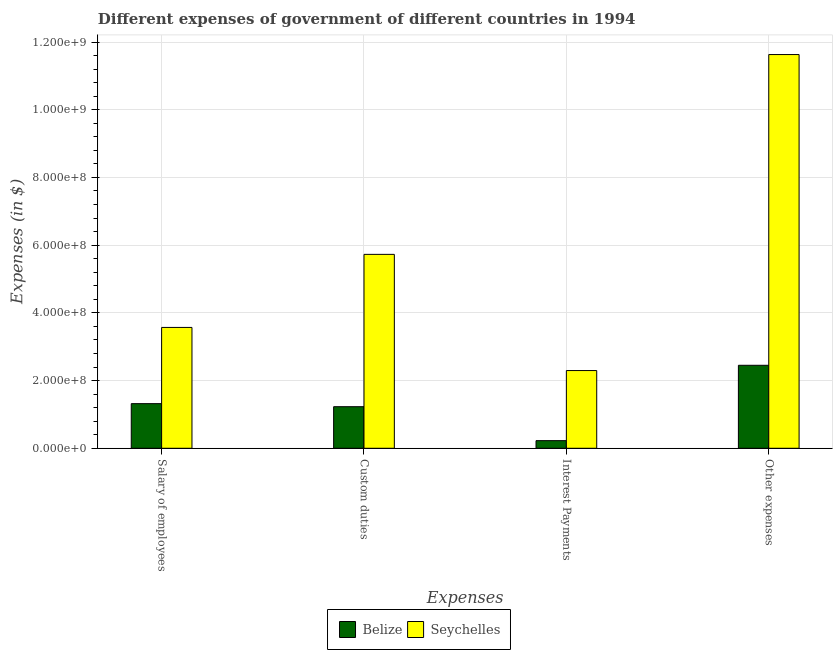How many different coloured bars are there?
Your response must be concise. 2. How many groups of bars are there?
Provide a succinct answer. 4. How many bars are there on the 3rd tick from the right?
Keep it short and to the point. 2. What is the label of the 3rd group of bars from the left?
Your answer should be compact. Interest Payments. What is the amount spent on interest payments in Belize?
Ensure brevity in your answer.  2.26e+07. Across all countries, what is the maximum amount spent on custom duties?
Ensure brevity in your answer.  5.73e+08. Across all countries, what is the minimum amount spent on interest payments?
Make the answer very short. 2.26e+07. In which country was the amount spent on salary of employees maximum?
Give a very brief answer. Seychelles. In which country was the amount spent on interest payments minimum?
Your answer should be very brief. Belize. What is the total amount spent on salary of employees in the graph?
Your answer should be compact. 4.89e+08. What is the difference between the amount spent on custom duties in Belize and that in Seychelles?
Keep it short and to the point. -4.50e+08. What is the difference between the amount spent on interest payments in Seychelles and the amount spent on custom duties in Belize?
Your answer should be compact. 1.07e+08. What is the average amount spent on custom duties per country?
Your answer should be very brief. 3.48e+08. What is the difference between the amount spent on other expenses and amount spent on custom duties in Seychelles?
Ensure brevity in your answer.  5.90e+08. In how many countries, is the amount spent on interest payments greater than 320000000 $?
Your answer should be very brief. 0. What is the ratio of the amount spent on salary of employees in Seychelles to that in Belize?
Your answer should be very brief. 2.71. Is the amount spent on interest payments in Belize less than that in Seychelles?
Provide a succinct answer. Yes. Is the difference between the amount spent on interest payments in Seychelles and Belize greater than the difference between the amount spent on other expenses in Seychelles and Belize?
Your answer should be compact. No. What is the difference between the highest and the second highest amount spent on custom duties?
Your response must be concise. 4.50e+08. What is the difference between the highest and the lowest amount spent on custom duties?
Offer a very short reply. 4.50e+08. Is the sum of the amount spent on other expenses in Seychelles and Belize greater than the maximum amount spent on custom duties across all countries?
Ensure brevity in your answer.  Yes. What does the 2nd bar from the left in Custom duties represents?
Give a very brief answer. Seychelles. What does the 2nd bar from the right in Custom duties represents?
Give a very brief answer. Belize. Is it the case that in every country, the sum of the amount spent on salary of employees and amount spent on custom duties is greater than the amount spent on interest payments?
Offer a terse response. Yes. How many countries are there in the graph?
Your response must be concise. 2. Are the values on the major ticks of Y-axis written in scientific E-notation?
Provide a succinct answer. Yes. How are the legend labels stacked?
Provide a short and direct response. Horizontal. What is the title of the graph?
Provide a succinct answer. Different expenses of government of different countries in 1994. What is the label or title of the X-axis?
Provide a short and direct response. Expenses. What is the label or title of the Y-axis?
Keep it short and to the point. Expenses (in $). What is the Expenses (in $) of Belize in Salary of employees?
Keep it short and to the point. 1.32e+08. What is the Expenses (in $) of Seychelles in Salary of employees?
Keep it short and to the point. 3.57e+08. What is the Expenses (in $) of Belize in Custom duties?
Your answer should be very brief. 1.23e+08. What is the Expenses (in $) of Seychelles in Custom duties?
Your response must be concise. 5.73e+08. What is the Expenses (in $) in Belize in Interest Payments?
Your response must be concise. 2.26e+07. What is the Expenses (in $) in Seychelles in Interest Payments?
Give a very brief answer. 2.30e+08. What is the Expenses (in $) of Belize in Other expenses?
Your answer should be very brief. 2.45e+08. What is the Expenses (in $) of Seychelles in Other expenses?
Your answer should be very brief. 1.16e+09. Across all Expenses, what is the maximum Expenses (in $) in Belize?
Provide a short and direct response. 2.45e+08. Across all Expenses, what is the maximum Expenses (in $) of Seychelles?
Your answer should be very brief. 1.16e+09. Across all Expenses, what is the minimum Expenses (in $) of Belize?
Your response must be concise. 2.26e+07. Across all Expenses, what is the minimum Expenses (in $) of Seychelles?
Offer a terse response. 2.30e+08. What is the total Expenses (in $) in Belize in the graph?
Your answer should be very brief. 5.22e+08. What is the total Expenses (in $) of Seychelles in the graph?
Make the answer very short. 2.32e+09. What is the difference between the Expenses (in $) in Belize in Salary of employees and that in Custom duties?
Your response must be concise. 9.03e+06. What is the difference between the Expenses (in $) of Seychelles in Salary of employees and that in Custom duties?
Ensure brevity in your answer.  -2.16e+08. What is the difference between the Expenses (in $) of Belize in Salary of employees and that in Interest Payments?
Provide a succinct answer. 1.09e+08. What is the difference between the Expenses (in $) in Seychelles in Salary of employees and that in Interest Payments?
Provide a short and direct response. 1.27e+08. What is the difference between the Expenses (in $) of Belize in Salary of employees and that in Other expenses?
Provide a succinct answer. -1.13e+08. What is the difference between the Expenses (in $) of Seychelles in Salary of employees and that in Other expenses?
Ensure brevity in your answer.  -8.06e+08. What is the difference between the Expenses (in $) in Belize in Custom duties and that in Interest Payments?
Ensure brevity in your answer.  1.00e+08. What is the difference between the Expenses (in $) of Seychelles in Custom duties and that in Interest Payments?
Offer a very short reply. 3.43e+08. What is the difference between the Expenses (in $) of Belize in Custom duties and that in Other expenses?
Your response must be concise. -1.22e+08. What is the difference between the Expenses (in $) in Seychelles in Custom duties and that in Other expenses?
Offer a very short reply. -5.90e+08. What is the difference between the Expenses (in $) of Belize in Interest Payments and that in Other expenses?
Your response must be concise. -2.23e+08. What is the difference between the Expenses (in $) of Seychelles in Interest Payments and that in Other expenses?
Provide a succinct answer. -9.33e+08. What is the difference between the Expenses (in $) in Belize in Salary of employees and the Expenses (in $) in Seychelles in Custom duties?
Give a very brief answer. -4.41e+08. What is the difference between the Expenses (in $) of Belize in Salary of employees and the Expenses (in $) of Seychelles in Interest Payments?
Give a very brief answer. -9.77e+07. What is the difference between the Expenses (in $) in Belize in Salary of employees and the Expenses (in $) in Seychelles in Other expenses?
Keep it short and to the point. -1.03e+09. What is the difference between the Expenses (in $) in Belize in Custom duties and the Expenses (in $) in Seychelles in Interest Payments?
Your answer should be very brief. -1.07e+08. What is the difference between the Expenses (in $) in Belize in Custom duties and the Expenses (in $) in Seychelles in Other expenses?
Your answer should be very brief. -1.04e+09. What is the difference between the Expenses (in $) of Belize in Interest Payments and the Expenses (in $) of Seychelles in Other expenses?
Provide a succinct answer. -1.14e+09. What is the average Expenses (in $) of Belize per Expenses?
Your response must be concise. 1.31e+08. What is the average Expenses (in $) in Seychelles per Expenses?
Offer a very short reply. 5.81e+08. What is the difference between the Expenses (in $) in Belize and Expenses (in $) in Seychelles in Salary of employees?
Your answer should be very brief. -2.25e+08. What is the difference between the Expenses (in $) in Belize and Expenses (in $) in Seychelles in Custom duties?
Keep it short and to the point. -4.50e+08. What is the difference between the Expenses (in $) in Belize and Expenses (in $) in Seychelles in Interest Payments?
Ensure brevity in your answer.  -2.07e+08. What is the difference between the Expenses (in $) in Belize and Expenses (in $) in Seychelles in Other expenses?
Offer a terse response. -9.18e+08. What is the ratio of the Expenses (in $) of Belize in Salary of employees to that in Custom duties?
Provide a succinct answer. 1.07. What is the ratio of the Expenses (in $) of Seychelles in Salary of employees to that in Custom duties?
Provide a succinct answer. 0.62. What is the ratio of the Expenses (in $) in Belize in Salary of employees to that in Interest Payments?
Your answer should be very brief. 5.85. What is the ratio of the Expenses (in $) of Seychelles in Salary of employees to that in Interest Payments?
Make the answer very short. 1.55. What is the ratio of the Expenses (in $) of Belize in Salary of employees to that in Other expenses?
Give a very brief answer. 0.54. What is the ratio of the Expenses (in $) of Seychelles in Salary of employees to that in Other expenses?
Provide a short and direct response. 0.31. What is the ratio of the Expenses (in $) of Belize in Custom duties to that in Interest Payments?
Your response must be concise. 5.45. What is the ratio of the Expenses (in $) in Seychelles in Custom duties to that in Interest Payments?
Your answer should be compact. 2.49. What is the ratio of the Expenses (in $) of Belize in Custom duties to that in Other expenses?
Provide a succinct answer. 0.5. What is the ratio of the Expenses (in $) in Seychelles in Custom duties to that in Other expenses?
Your answer should be very brief. 0.49. What is the ratio of the Expenses (in $) in Belize in Interest Payments to that in Other expenses?
Offer a terse response. 0.09. What is the ratio of the Expenses (in $) in Seychelles in Interest Payments to that in Other expenses?
Offer a very short reply. 0.2. What is the difference between the highest and the second highest Expenses (in $) in Belize?
Give a very brief answer. 1.13e+08. What is the difference between the highest and the second highest Expenses (in $) of Seychelles?
Ensure brevity in your answer.  5.90e+08. What is the difference between the highest and the lowest Expenses (in $) of Belize?
Offer a very short reply. 2.23e+08. What is the difference between the highest and the lowest Expenses (in $) of Seychelles?
Offer a very short reply. 9.33e+08. 